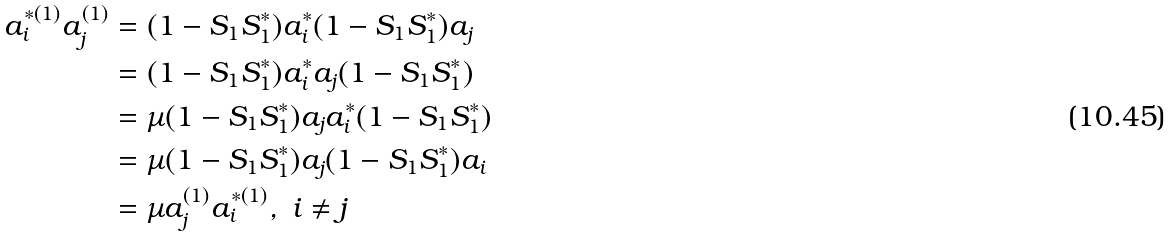Convert formula to latex. <formula><loc_0><loc_0><loc_500><loc_500>a _ { i } ^ { * ( 1 ) } a _ { j } ^ { ( 1 ) } & = ( 1 - S _ { 1 } S _ { 1 } ^ { * } ) a _ { i } ^ { * } ( 1 - S _ { 1 } S _ { 1 } ^ { * } ) a _ { j } \\ & = ( 1 - S _ { 1 } S _ { 1 } ^ { * } ) a _ { i } ^ { * } a _ { j } ( 1 - S _ { 1 } S _ { 1 } ^ { * } ) \\ & = \mu ( 1 - S _ { 1 } S _ { 1 } ^ { * } ) a _ { j } a _ { i } ^ { * } ( 1 - S _ { 1 } S _ { 1 } ^ { * } ) \\ & = \mu ( 1 - S _ { 1 } S _ { 1 } ^ { * } ) a _ { j } ( 1 - S _ { 1 } S _ { 1 } ^ { * } ) a _ { i } \\ & = \mu a _ { j } ^ { ( 1 ) } a _ { i } ^ { * ( 1 ) } , \ i \ne j</formula> 